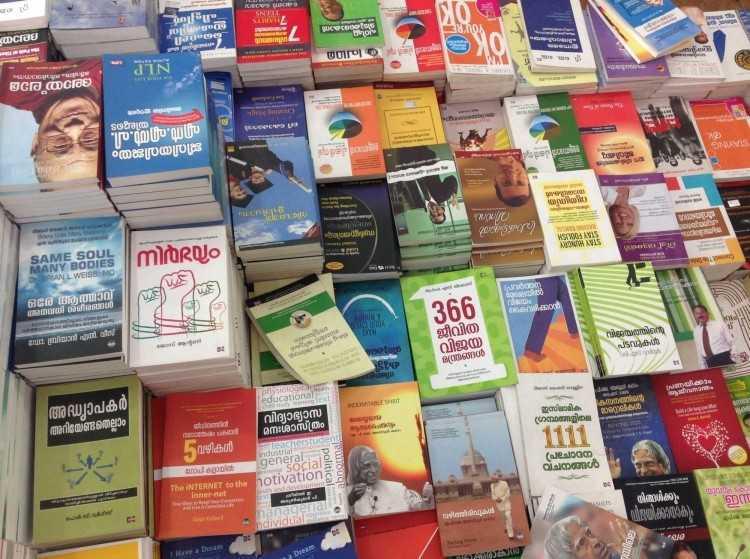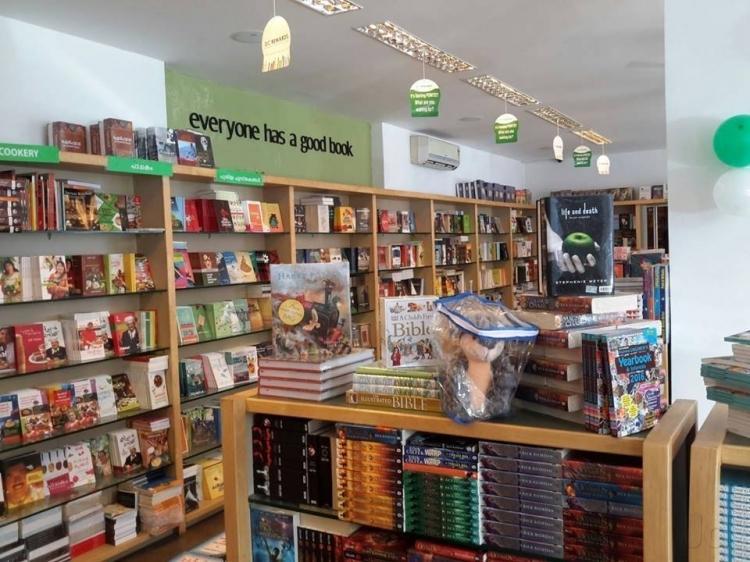The first image is the image on the left, the second image is the image on the right. Examine the images to the left and right. Is the description "A bookstore image includes a green balloon and a variety of green signage." accurate? Answer yes or no. Yes. 